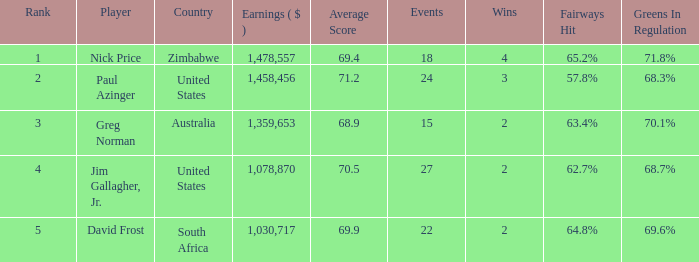How many events are in South Africa? 22.0. 